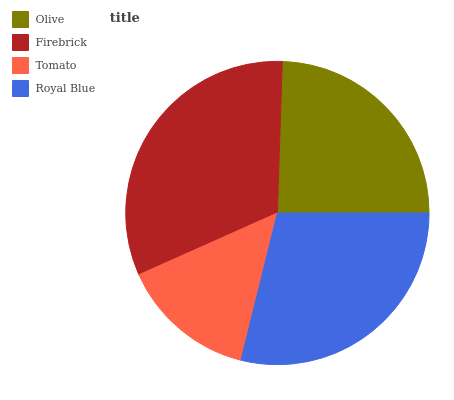Is Tomato the minimum?
Answer yes or no. Yes. Is Firebrick the maximum?
Answer yes or no. Yes. Is Firebrick the minimum?
Answer yes or no. No. Is Tomato the maximum?
Answer yes or no. No. Is Firebrick greater than Tomato?
Answer yes or no. Yes. Is Tomato less than Firebrick?
Answer yes or no. Yes. Is Tomato greater than Firebrick?
Answer yes or no. No. Is Firebrick less than Tomato?
Answer yes or no. No. Is Royal Blue the high median?
Answer yes or no. Yes. Is Olive the low median?
Answer yes or no. Yes. Is Olive the high median?
Answer yes or no. No. Is Tomato the low median?
Answer yes or no. No. 